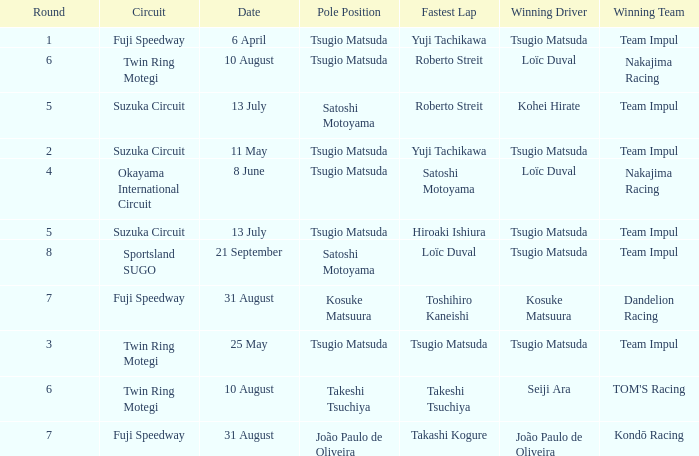What is the fastest lap for Seiji Ara? Takeshi Tsuchiya. 